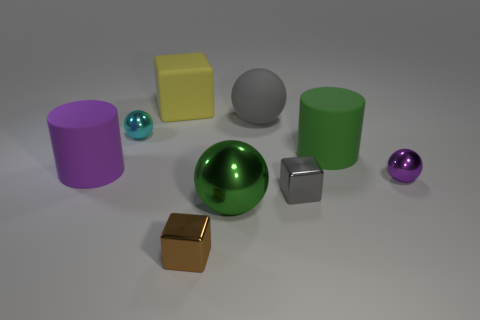Subtract all red cylinders. Subtract all green spheres. How many cylinders are left? 2 Add 1 small red matte cubes. How many objects exist? 10 Subtract all balls. How many objects are left? 5 Add 2 small brown metal cubes. How many small brown metal cubes are left? 3 Add 7 blue metal things. How many blue metal things exist? 7 Subtract 0 yellow cylinders. How many objects are left? 9 Subtract all brown matte balls. Subtract all large cylinders. How many objects are left? 7 